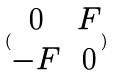Convert formula to latex. <formula><loc_0><loc_0><loc_500><loc_500>( \begin{matrix} 0 & F \\ - F & 0 \end{matrix} )</formula> 